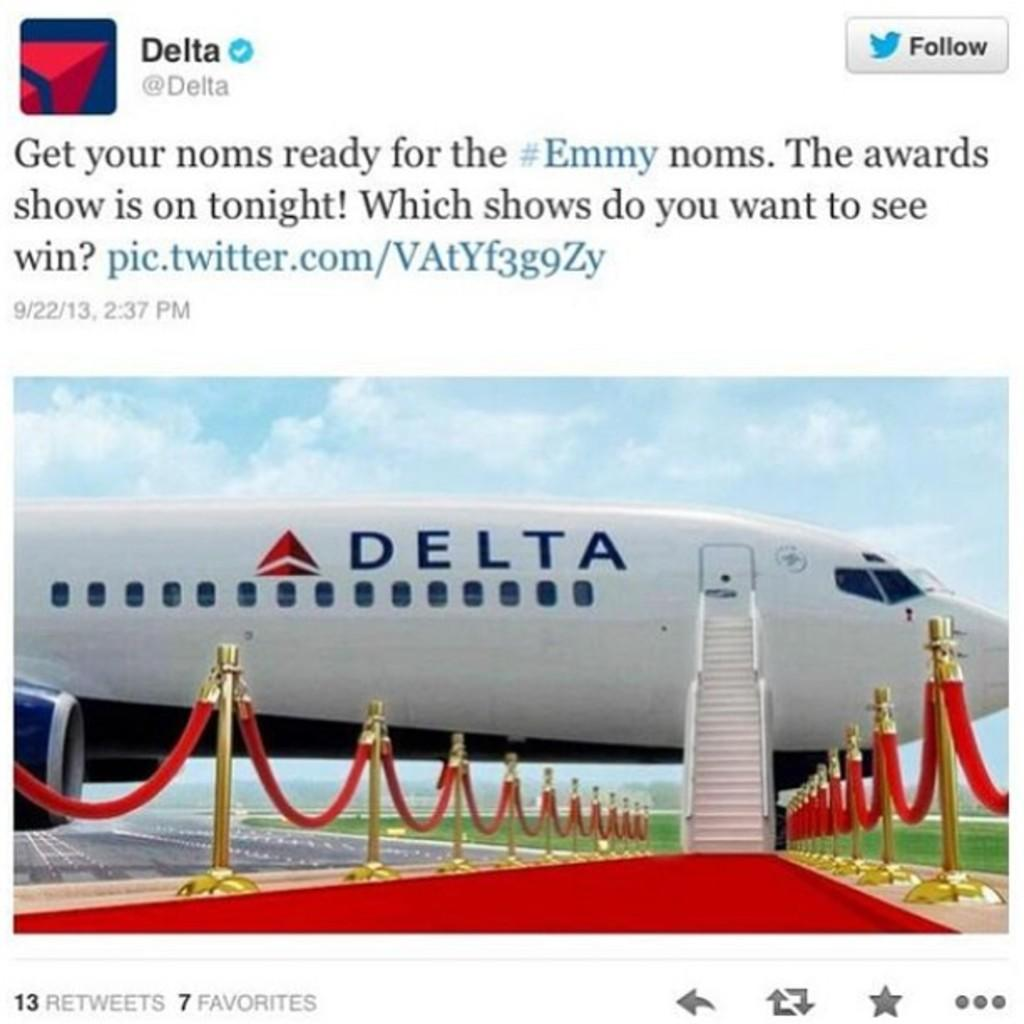<image>
Give a short and clear explanation of the subsequent image. A twitter post from Delta airlines about Emmy awards show. 